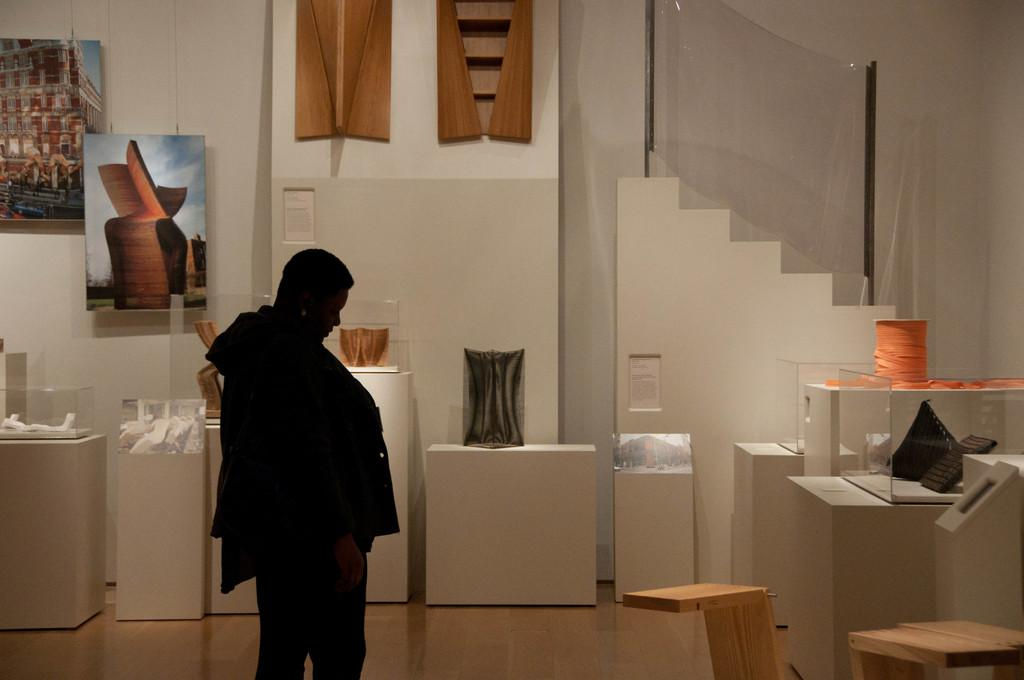Who is present in the image? There is a woman in the image. What is in front of the woman? There are objects on a table in front of the woman. What can be seen on the wall in the image? There are paintings on the wall in the image. Where is the goose located in the image? There is no goose present in the image. How many icicles are hanging from the woman's hair in the image? There are no icicles present in the image. 